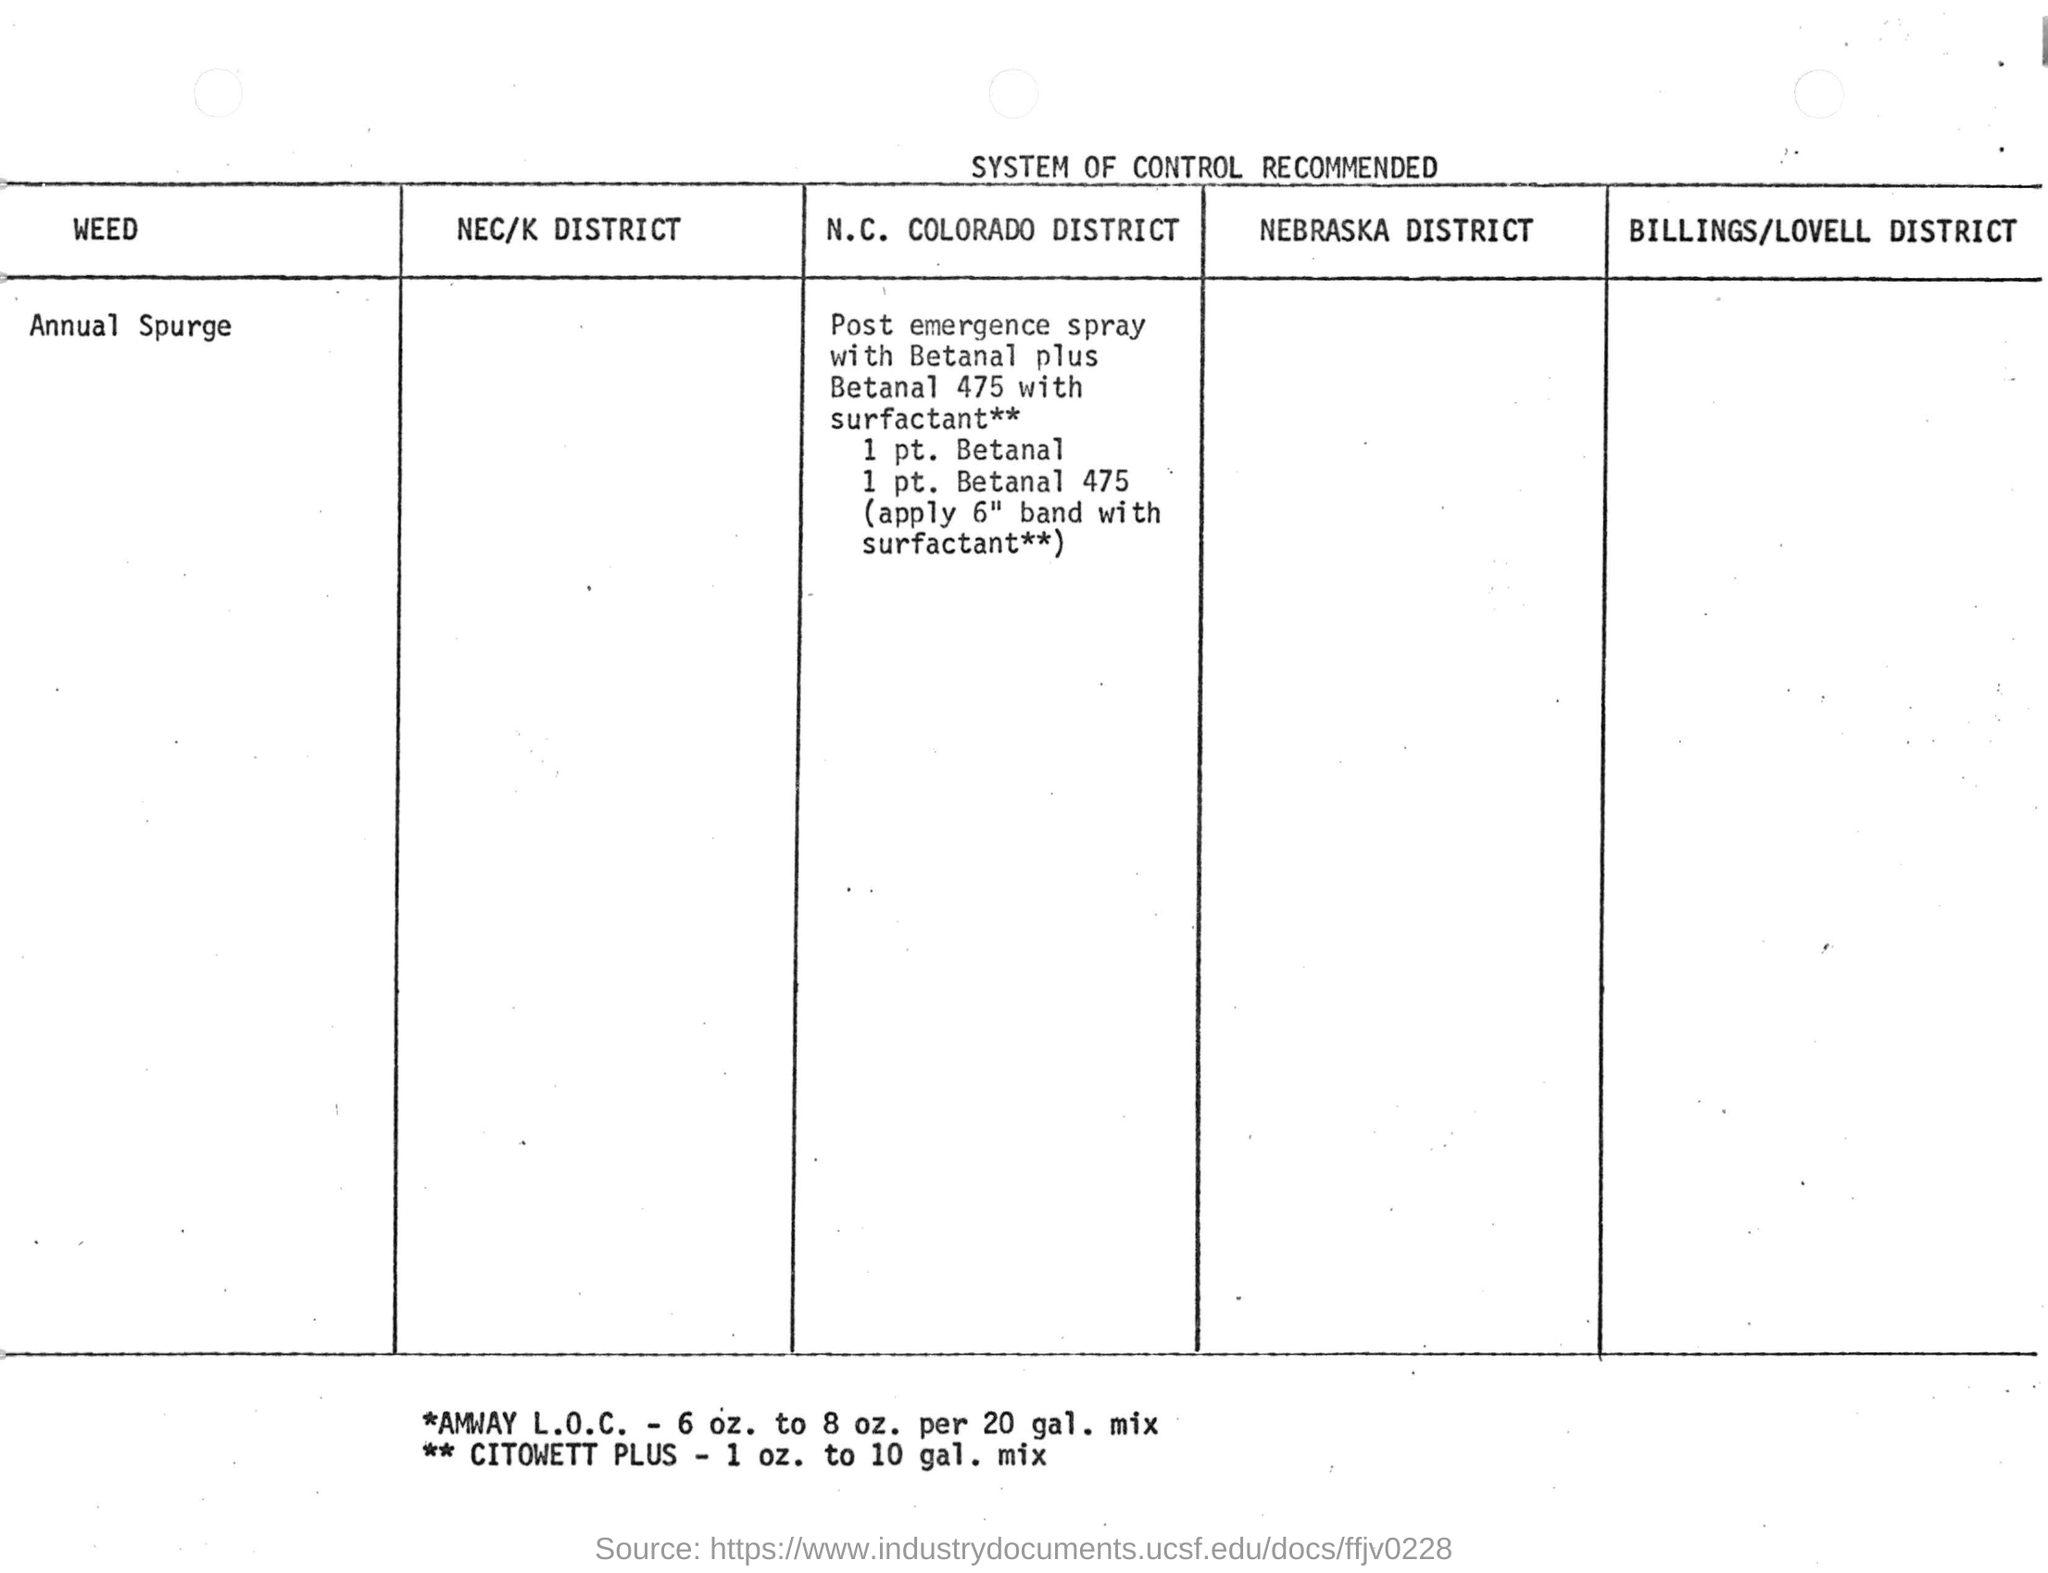Indicate a few pertinent items in this graphic. Annual spurge is the specific weed that requires control. The amount of surfactant applied to control annual spurge weed is 6. In the Colorado district, it is necessary to control annual spurge using post-emergence spraying. 